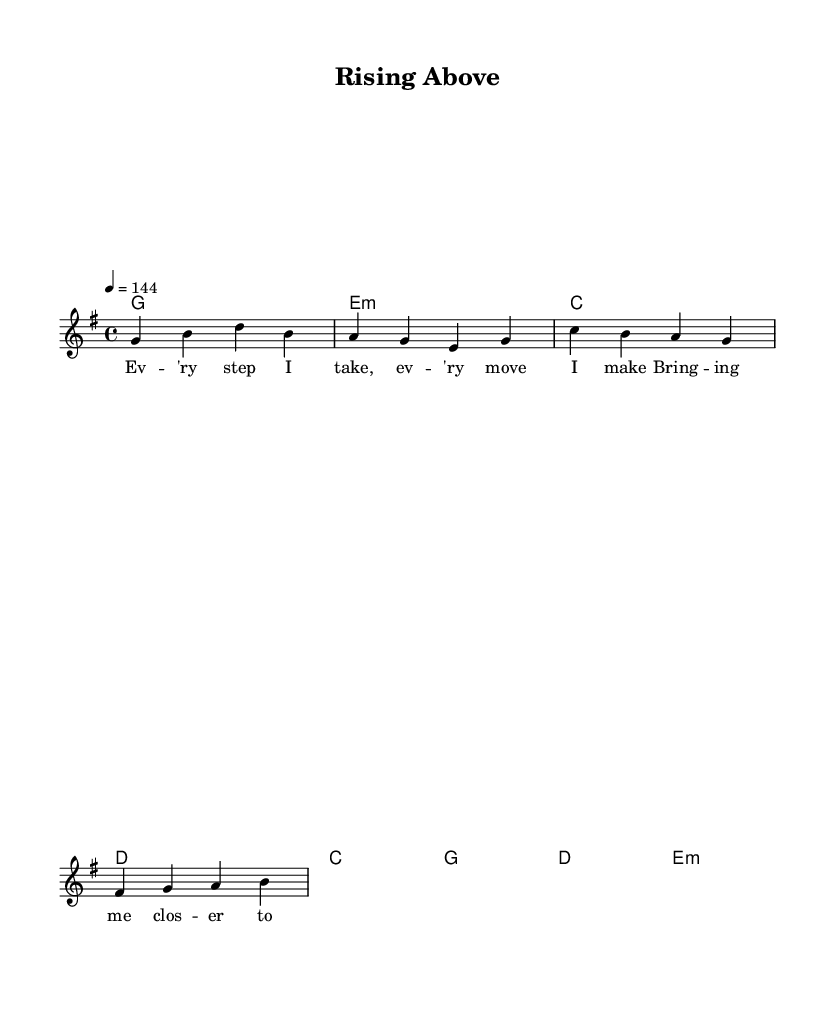What is the key signature of this music? The key signature is G major, which has one sharp (F#). This can be identified by looking at the key signature symbol at the beginning of the staff.
Answer: G major What is the time signature? The time signature is 4/4, indicated at the beginning of the score. This means there are 4 beats in each measure and the quarter note gets one beat.
Answer: 4/4 What is the tempo marking? The tempo marking is 144 beats per minute, as specified at the beginning with "4 = 144". This indicates the speed of the music.
Answer: 144 How many measures are in the verse melody? The verse melody consists of 2 measures. This can be found by counting the grouped notes and their corresponding bar lines in the melodyVerse portion.
Answer: 2 What chords are used in the chorus? The chorus uses C, G, D, and E minor chords, as stated in the chordmode for the chorusChords section.
Answer: C, G, D, E minor In which section of the song is the phrase "I'm rising, rising above the doubt"? This phrase appears in the chorus lyrics, which are located under the melodyChorus. The lyrics are associated directly with the chorus section of the song.
Answer: Chorus What is the emotional tone conveyed in the lyrics? The tone conveyed is one of positivity and resilience, as the lyrics point towards personal growth and overcoming challenges, which is typical of upbeat alternative rock songs.
Answer: Positive 